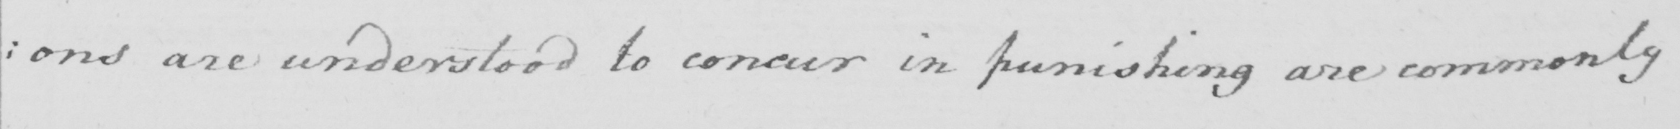Transcribe the text shown in this historical manuscript line. : ons are understood to concur in punishing are commonly 